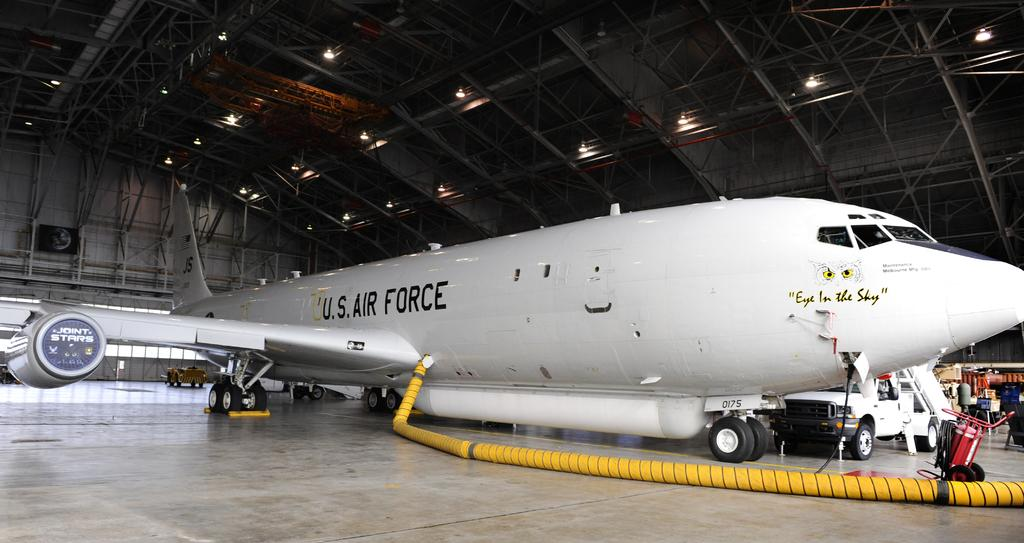What is the main subject of the picture? The main subject of the picture is an aircraft. What else can be seen in the picture besides the aircraft? There are vehicles, devices, a roof, and lights visible in the picture. Can you describe the text on the aircraft? Yes, there is text on the aircraft. Where is the yard located in the image? There is no yard present in the image. What type of berry is growing on the roof in the image? There are no berries visible in the image, and the roof is not described as having any vegetation. 